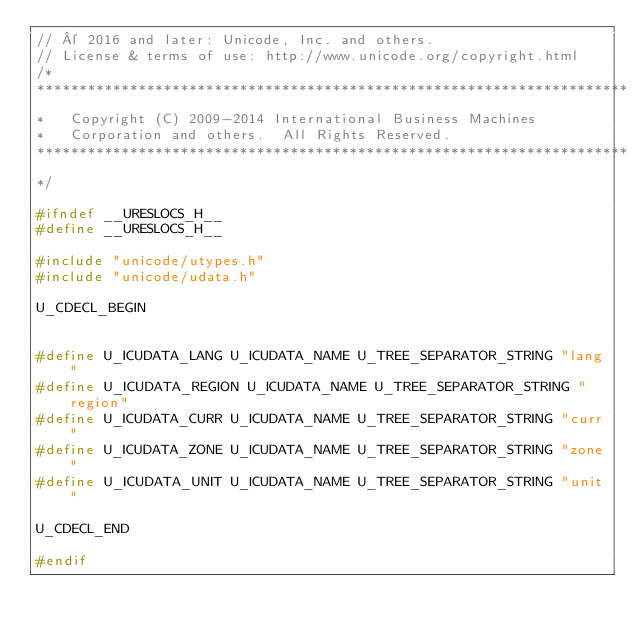<code> <loc_0><loc_0><loc_500><loc_500><_C_>// © 2016 and later: Unicode, Inc. and others.
// License & terms of use: http://www.unicode.org/copyright.html
/*
**********************************************************************
*   Copyright (C) 2009-2014 International Business Machines
*   Corporation and others.  All Rights Reserved.
**********************************************************************
*/

#ifndef __URESLOCS_H__
#define __URESLOCS_H__

#include "unicode/utypes.h"
#include "unicode/udata.h"

U_CDECL_BEGIN


#define U_ICUDATA_LANG U_ICUDATA_NAME U_TREE_SEPARATOR_STRING "lang"
#define U_ICUDATA_REGION U_ICUDATA_NAME U_TREE_SEPARATOR_STRING "region"
#define U_ICUDATA_CURR U_ICUDATA_NAME U_TREE_SEPARATOR_STRING "curr"
#define U_ICUDATA_ZONE U_ICUDATA_NAME U_TREE_SEPARATOR_STRING "zone"
#define U_ICUDATA_UNIT U_ICUDATA_NAME U_TREE_SEPARATOR_STRING "unit"

U_CDECL_END

#endif
</code> 